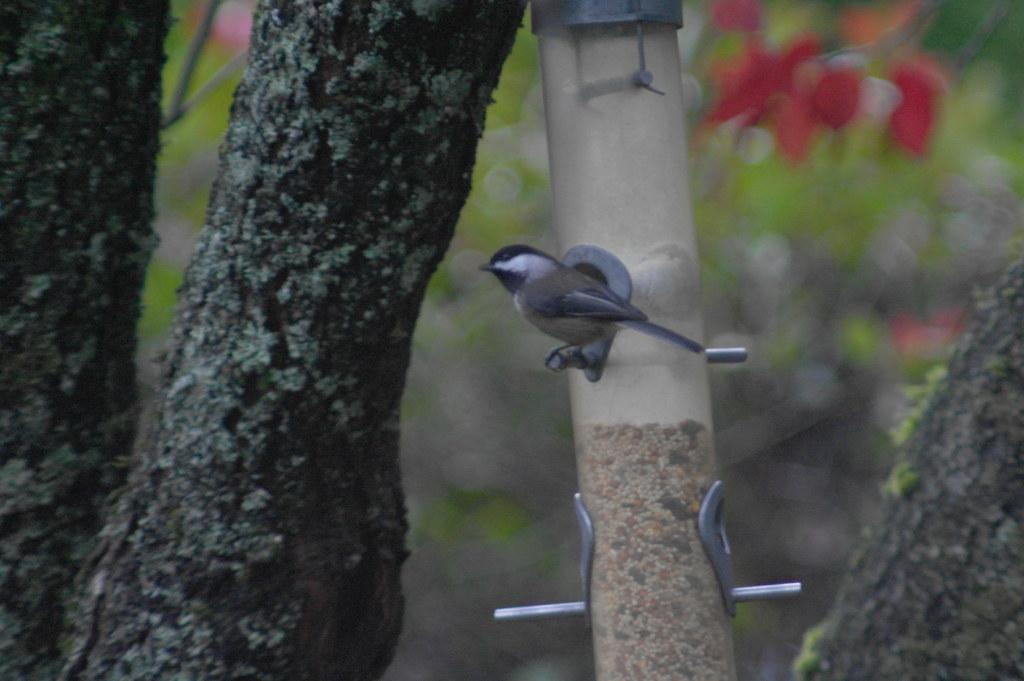What is there is a bird perched on what object in the image? There is a bird on a pole in the image. What type of vegetation can be seen on the left side of the image? There is a tree on the left side of the image. Can you describe the background of the image? The background of the image is blurred. How many beds are visible in the image? There are no beds present in the image. What type of mint is growing near the tree in the image? There is no mint visible in the image, and the tree is the only vegetation mentioned. 